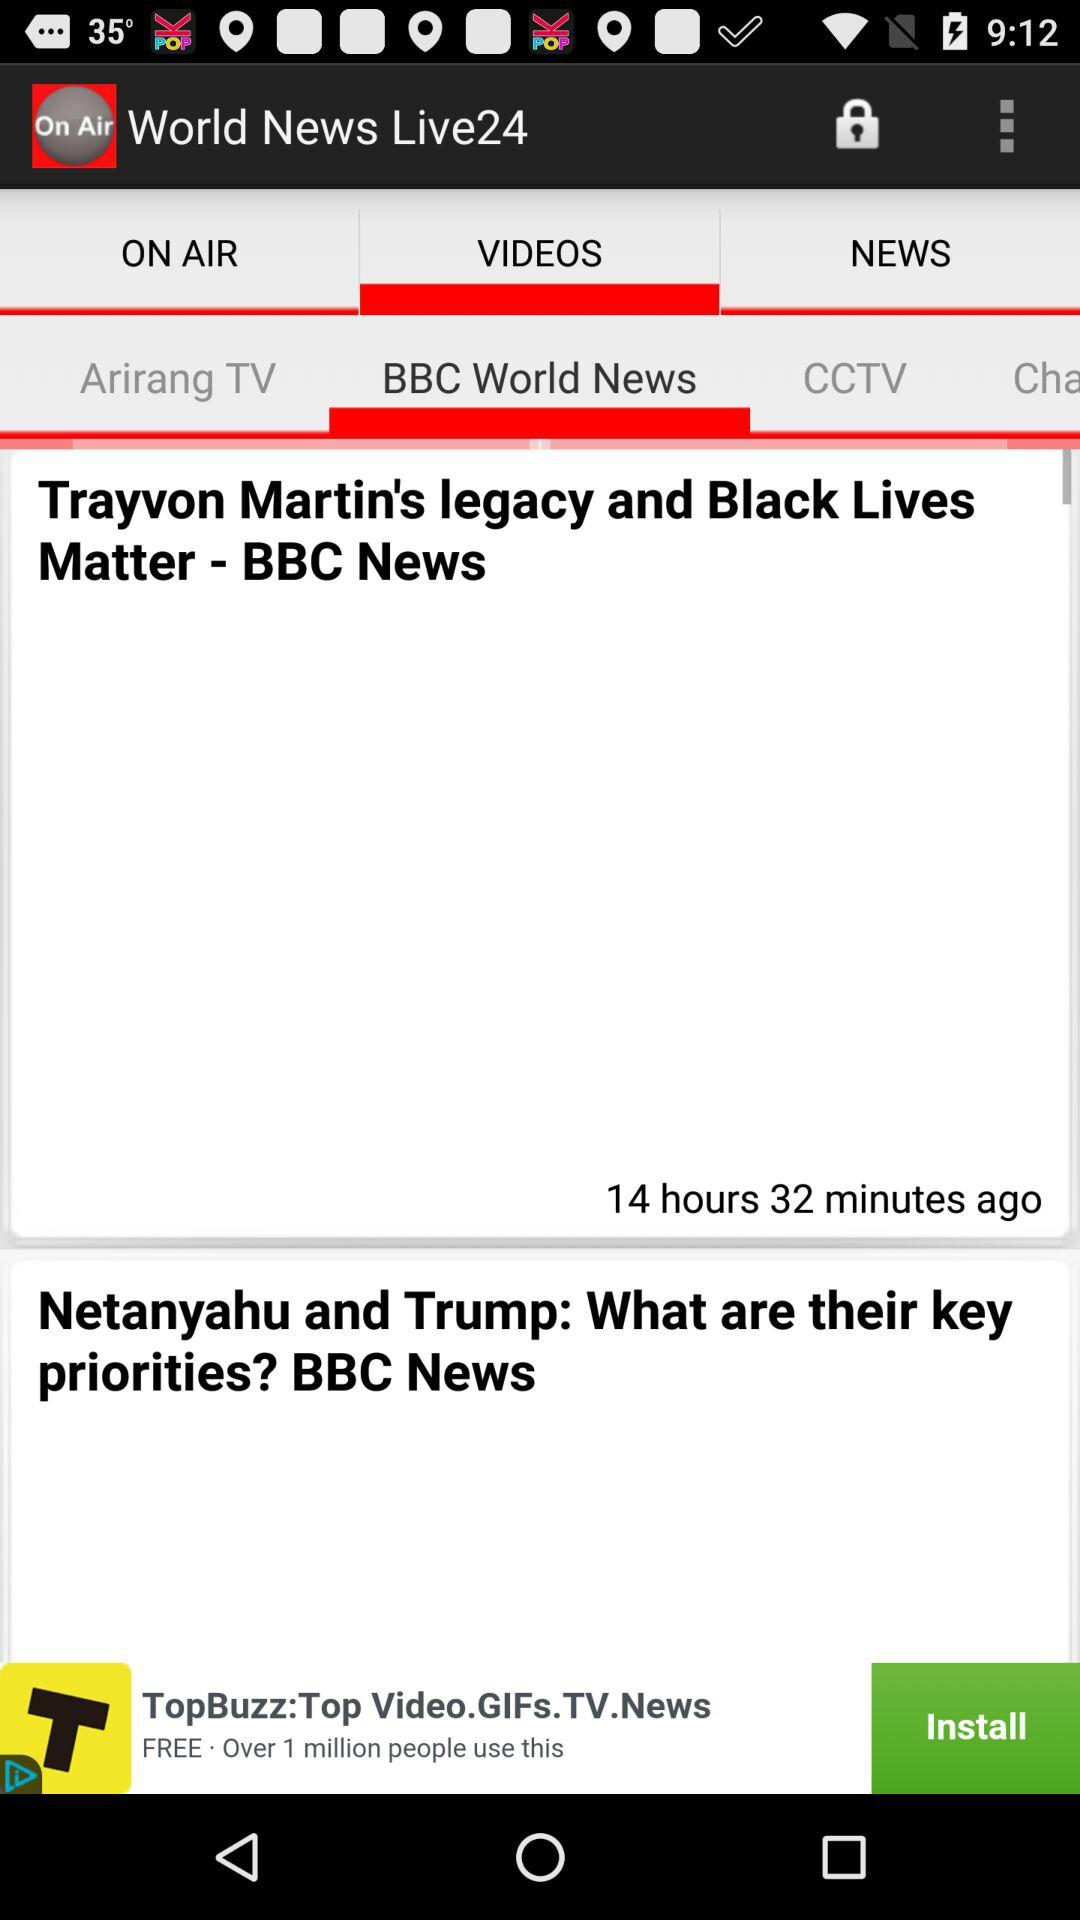Who posted the news about Trayvon Martin's legacy? The news was posted by BBC News. 